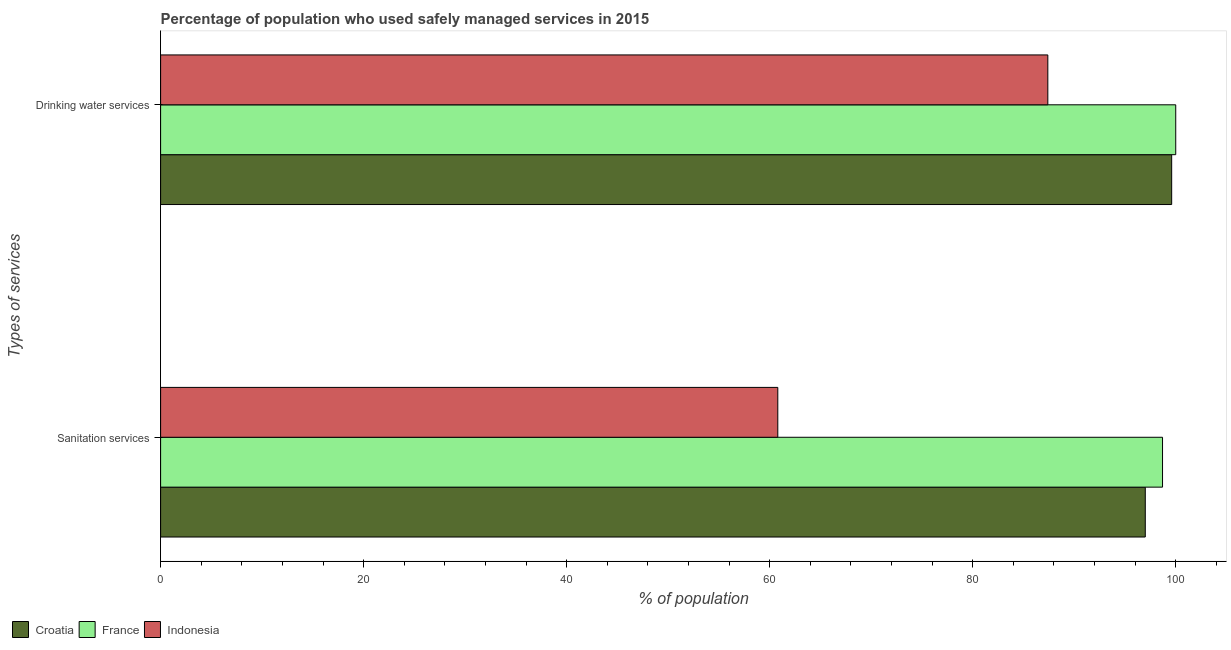How many groups of bars are there?
Your answer should be compact. 2. Are the number of bars per tick equal to the number of legend labels?
Make the answer very short. Yes. What is the label of the 1st group of bars from the top?
Your answer should be very brief. Drinking water services. Across all countries, what is the maximum percentage of population who used drinking water services?
Your answer should be very brief. 100. Across all countries, what is the minimum percentage of population who used sanitation services?
Provide a short and direct response. 60.8. What is the total percentage of population who used drinking water services in the graph?
Give a very brief answer. 287. What is the difference between the percentage of population who used sanitation services in Croatia and that in Indonesia?
Ensure brevity in your answer.  36.2. What is the average percentage of population who used drinking water services per country?
Your answer should be compact. 95.67. What is the difference between the percentage of population who used drinking water services and percentage of population who used sanitation services in Indonesia?
Ensure brevity in your answer.  26.6. In how many countries, is the percentage of population who used drinking water services greater than 72 %?
Keep it short and to the point. 3. What is the ratio of the percentage of population who used drinking water services in France to that in Croatia?
Make the answer very short. 1. In how many countries, is the percentage of population who used drinking water services greater than the average percentage of population who used drinking water services taken over all countries?
Provide a short and direct response. 2. What does the 2nd bar from the top in Drinking water services represents?
Your answer should be compact. France. What does the 1st bar from the bottom in Sanitation services represents?
Your answer should be compact. Croatia. How many bars are there?
Offer a terse response. 6. How many countries are there in the graph?
Offer a very short reply. 3. Are the values on the major ticks of X-axis written in scientific E-notation?
Your response must be concise. No. Does the graph contain any zero values?
Provide a succinct answer. No. Where does the legend appear in the graph?
Ensure brevity in your answer.  Bottom left. How are the legend labels stacked?
Ensure brevity in your answer.  Horizontal. What is the title of the graph?
Your response must be concise. Percentage of population who used safely managed services in 2015. What is the label or title of the X-axis?
Offer a terse response. % of population. What is the label or title of the Y-axis?
Your response must be concise. Types of services. What is the % of population in Croatia in Sanitation services?
Give a very brief answer. 97. What is the % of population of France in Sanitation services?
Ensure brevity in your answer.  98.7. What is the % of population in Indonesia in Sanitation services?
Your answer should be very brief. 60.8. What is the % of population in Croatia in Drinking water services?
Provide a succinct answer. 99.6. What is the % of population in Indonesia in Drinking water services?
Provide a short and direct response. 87.4. Across all Types of services, what is the maximum % of population of Croatia?
Your response must be concise. 99.6. Across all Types of services, what is the maximum % of population of France?
Provide a succinct answer. 100. Across all Types of services, what is the maximum % of population in Indonesia?
Offer a very short reply. 87.4. Across all Types of services, what is the minimum % of population in Croatia?
Make the answer very short. 97. Across all Types of services, what is the minimum % of population of France?
Provide a succinct answer. 98.7. Across all Types of services, what is the minimum % of population of Indonesia?
Give a very brief answer. 60.8. What is the total % of population of Croatia in the graph?
Make the answer very short. 196.6. What is the total % of population in France in the graph?
Provide a short and direct response. 198.7. What is the total % of population in Indonesia in the graph?
Ensure brevity in your answer.  148.2. What is the difference between the % of population of France in Sanitation services and that in Drinking water services?
Your answer should be compact. -1.3. What is the difference between the % of population in Indonesia in Sanitation services and that in Drinking water services?
Your answer should be compact. -26.6. What is the difference between the % of population of Croatia in Sanitation services and the % of population of France in Drinking water services?
Your answer should be compact. -3. What is the difference between the % of population of Croatia in Sanitation services and the % of population of Indonesia in Drinking water services?
Provide a succinct answer. 9.6. What is the average % of population of Croatia per Types of services?
Provide a short and direct response. 98.3. What is the average % of population of France per Types of services?
Your answer should be compact. 99.35. What is the average % of population in Indonesia per Types of services?
Your response must be concise. 74.1. What is the difference between the % of population in Croatia and % of population in France in Sanitation services?
Keep it short and to the point. -1.7. What is the difference between the % of population in Croatia and % of population in Indonesia in Sanitation services?
Offer a terse response. 36.2. What is the difference between the % of population of France and % of population of Indonesia in Sanitation services?
Offer a very short reply. 37.9. What is the ratio of the % of population of Croatia in Sanitation services to that in Drinking water services?
Offer a very short reply. 0.97. What is the ratio of the % of population in France in Sanitation services to that in Drinking water services?
Keep it short and to the point. 0.99. What is the ratio of the % of population of Indonesia in Sanitation services to that in Drinking water services?
Provide a succinct answer. 0.7. What is the difference between the highest and the second highest % of population of Indonesia?
Ensure brevity in your answer.  26.6. What is the difference between the highest and the lowest % of population in Indonesia?
Your answer should be very brief. 26.6. 